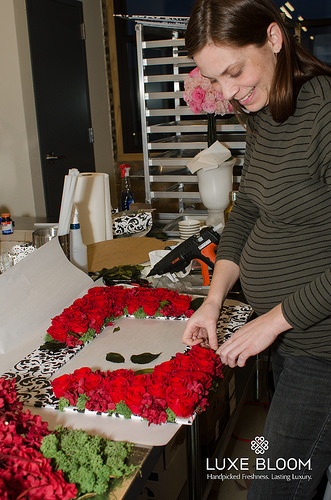<image>
Is there a flowers on the surface? Yes. Looking at the image, I can see the flowers is positioned on top of the surface, with the surface providing support. Where is the woman in relation to the flower? Is it on the flower? No. The woman is not positioned on the flower. They may be near each other, but the woman is not supported by or resting on top of the flower. 